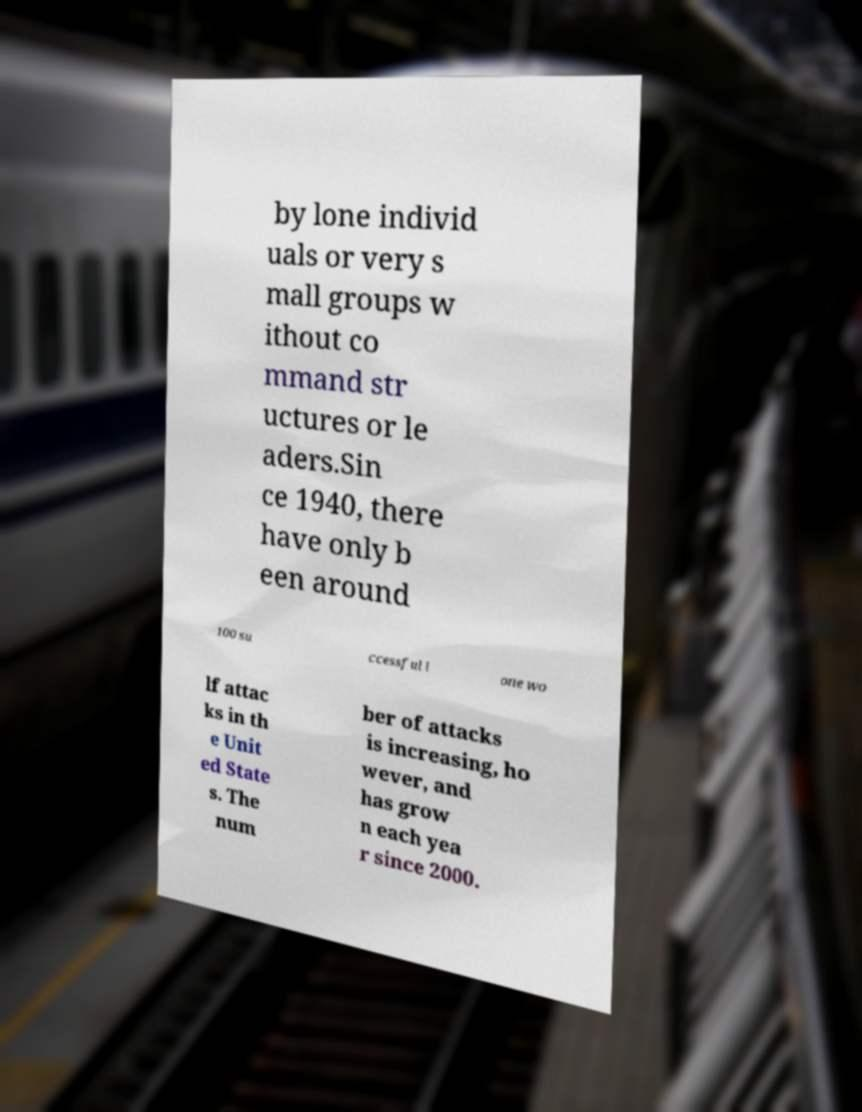What messages or text are displayed in this image? I need them in a readable, typed format. by lone individ uals or very s mall groups w ithout co mmand str uctures or le aders.Sin ce 1940, there have only b een around 100 su ccessful l one wo lf attac ks in th e Unit ed State s. The num ber of attacks is increasing, ho wever, and has grow n each yea r since 2000. 